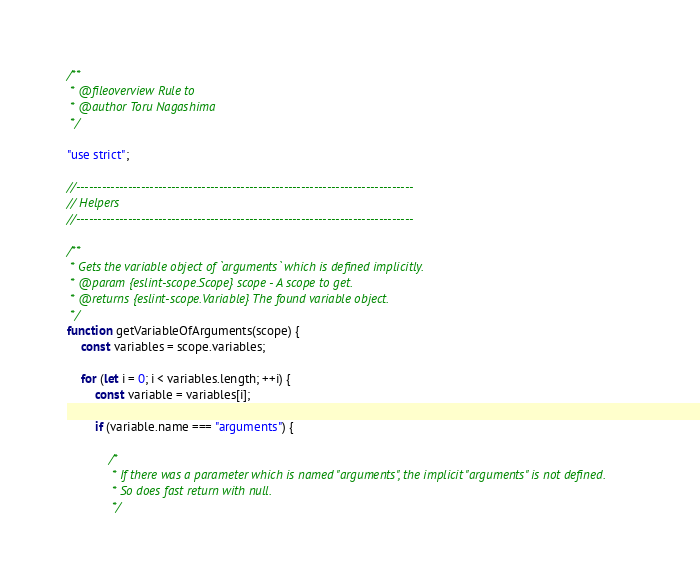Convert code to text. <code><loc_0><loc_0><loc_500><loc_500><_JavaScript_>/**
 * @fileoverview Rule to
 * @author Toru Nagashima
 */

"use strict";

//------------------------------------------------------------------------------
// Helpers
//------------------------------------------------------------------------------

/**
 * Gets the variable object of `arguments` which is defined implicitly.
 * @param {eslint-scope.Scope} scope - A scope to get.
 * @returns {eslint-scope.Variable} The found variable object.
 */
function getVariableOfArguments(scope) {
    const variables = scope.variables;

    for (let i = 0; i < variables.length; ++i) {
        const variable = variables[i];

        if (variable.name === "arguments") {

            /*
             * If there was a parameter which is named "arguments", the implicit "arguments" is not defined.
             * So does fast return with null.
             */</code> 